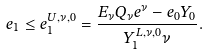Convert formula to latex. <formula><loc_0><loc_0><loc_500><loc_500>e _ { 1 } \leq e _ { 1 } ^ { U , \nu , 0 } = \frac { E _ { \nu } Q _ { \nu } e ^ { \nu } - e _ { 0 } Y _ { 0 } } { Y _ { 1 } ^ { L , \nu , 0 } \nu } .</formula> 